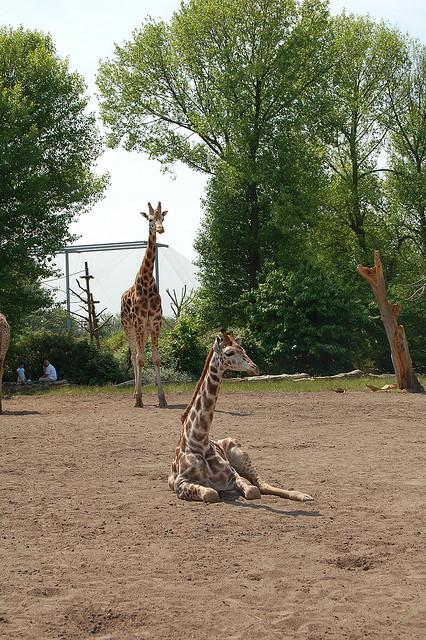What is the giraffe in the foreground doing? Please explain your reasoning. sitting. The animal is resting on the ground. 